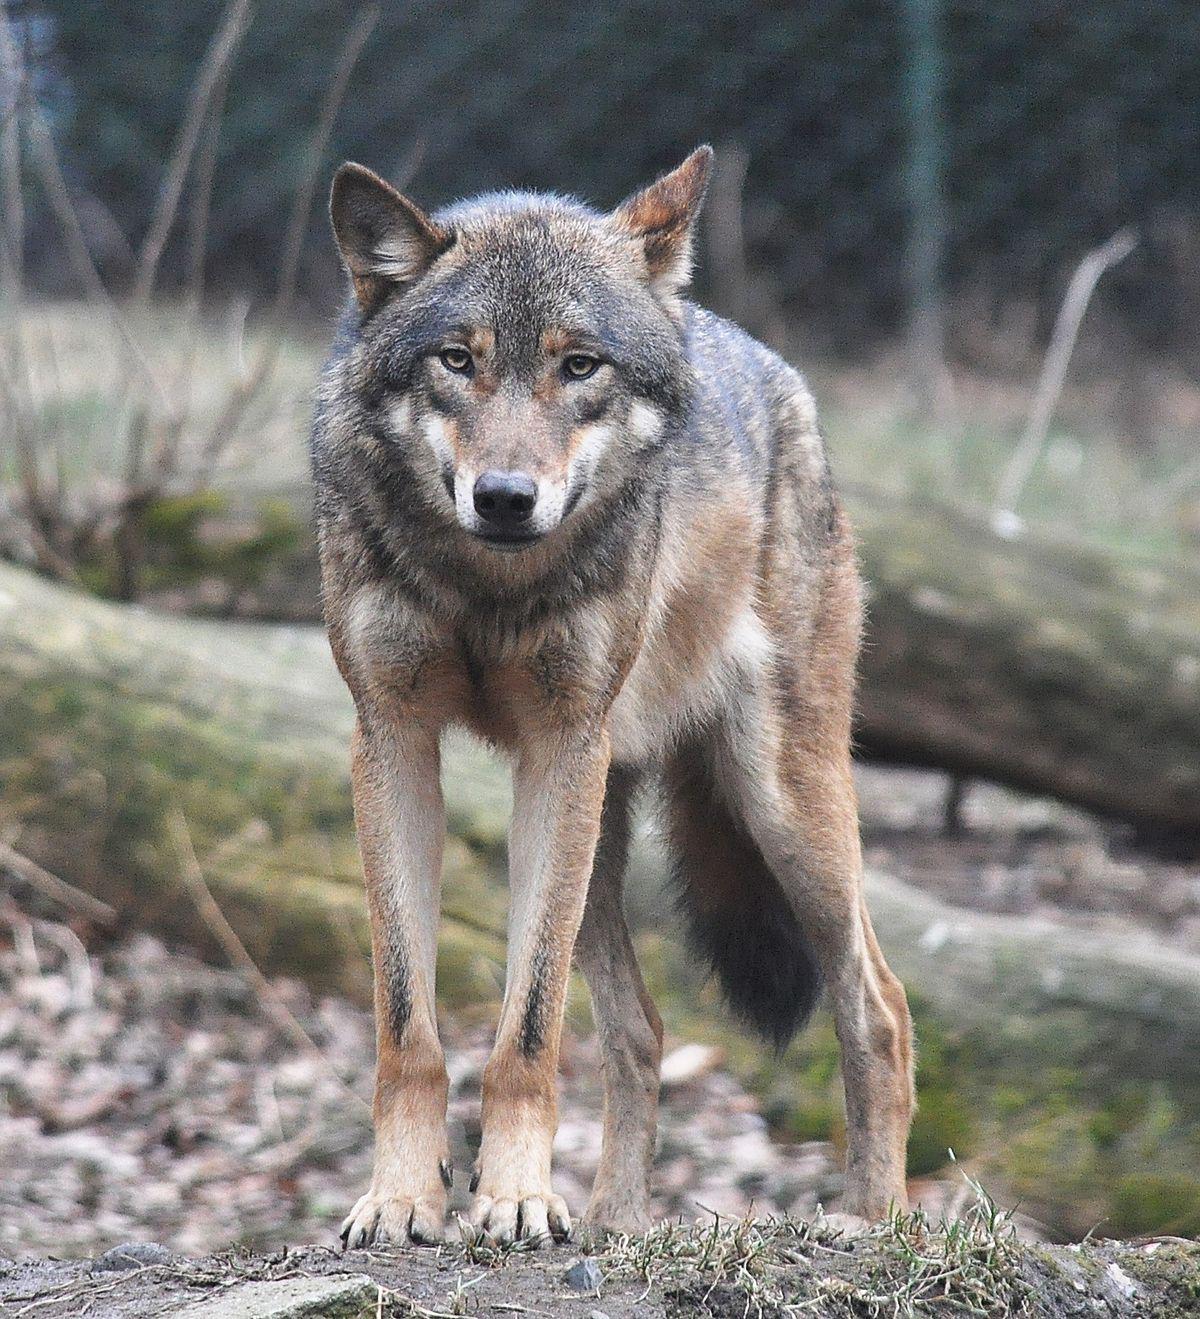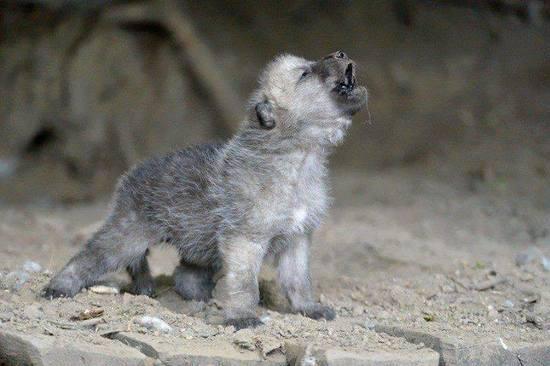The first image is the image on the left, the second image is the image on the right. For the images displayed, is the sentence "There is exactly one animal with its mouth open in one of the images." factually correct? Answer yes or no. Yes. 